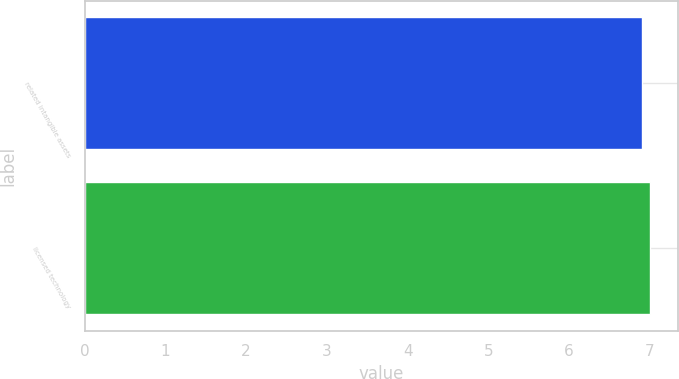Convert chart to OTSL. <chart><loc_0><loc_0><loc_500><loc_500><bar_chart><fcel>related intangible assets<fcel>licensed technology<nl><fcel>6.9<fcel>7<nl></chart> 